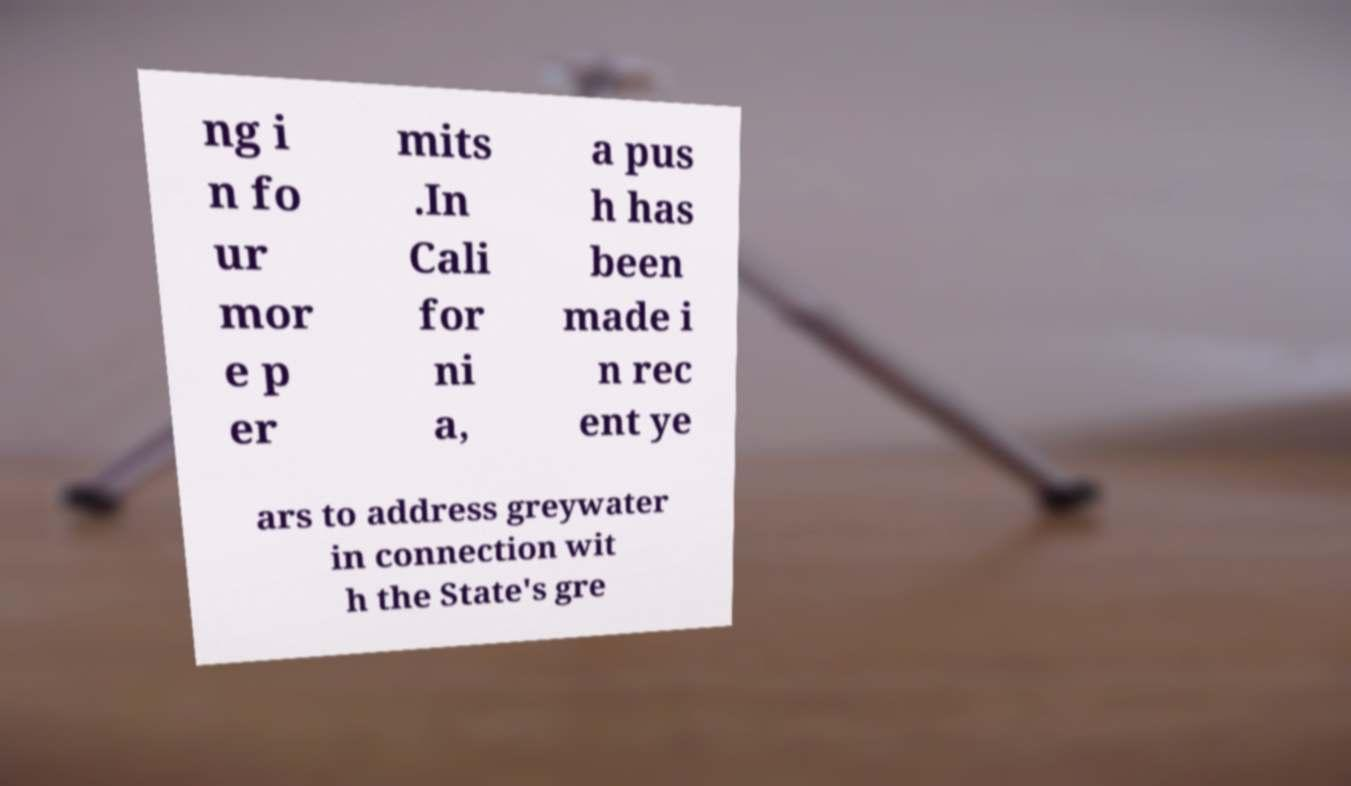Could you assist in decoding the text presented in this image and type it out clearly? ng i n fo ur mor e p er mits .In Cali for ni a, a pus h has been made i n rec ent ye ars to address greywater in connection wit h the State's gre 